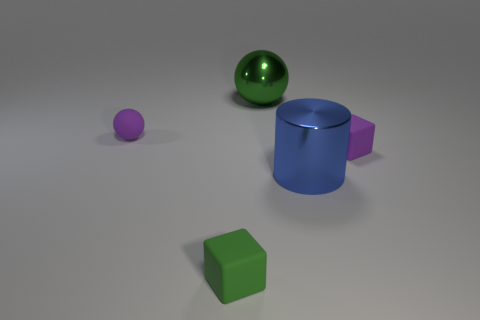Add 2 shiny objects. How many objects exist? 7 Subtract all balls. How many objects are left? 3 Subtract all cyan matte cylinders. Subtract all shiny objects. How many objects are left? 3 Add 1 large green spheres. How many large green spheres are left? 2 Add 3 big objects. How many big objects exist? 5 Subtract 1 blue cylinders. How many objects are left? 4 